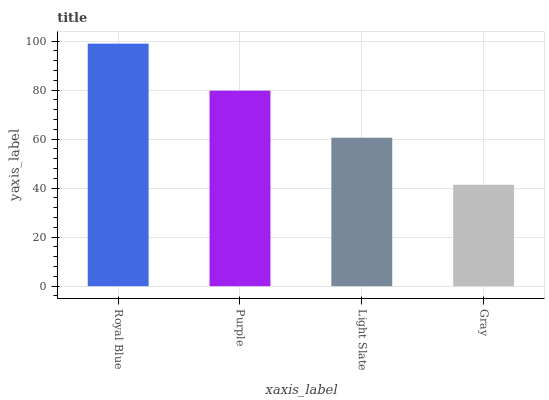Is Gray the minimum?
Answer yes or no. Yes. Is Royal Blue the maximum?
Answer yes or no. Yes. Is Purple the minimum?
Answer yes or no. No. Is Purple the maximum?
Answer yes or no. No. Is Royal Blue greater than Purple?
Answer yes or no. Yes. Is Purple less than Royal Blue?
Answer yes or no. Yes. Is Purple greater than Royal Blue?
Answer yes or no. No. Is Royal Blue less than Purple?
Answer yes or no. No. Is Purple the high median?
Answer yes or no. Yes. Is Light Slate the low median?
Answer yes or no. Yes. Is Gray the high median?
Answer yes or no. No. Is Royal Blue the low median?
Answer yes or no. No. 